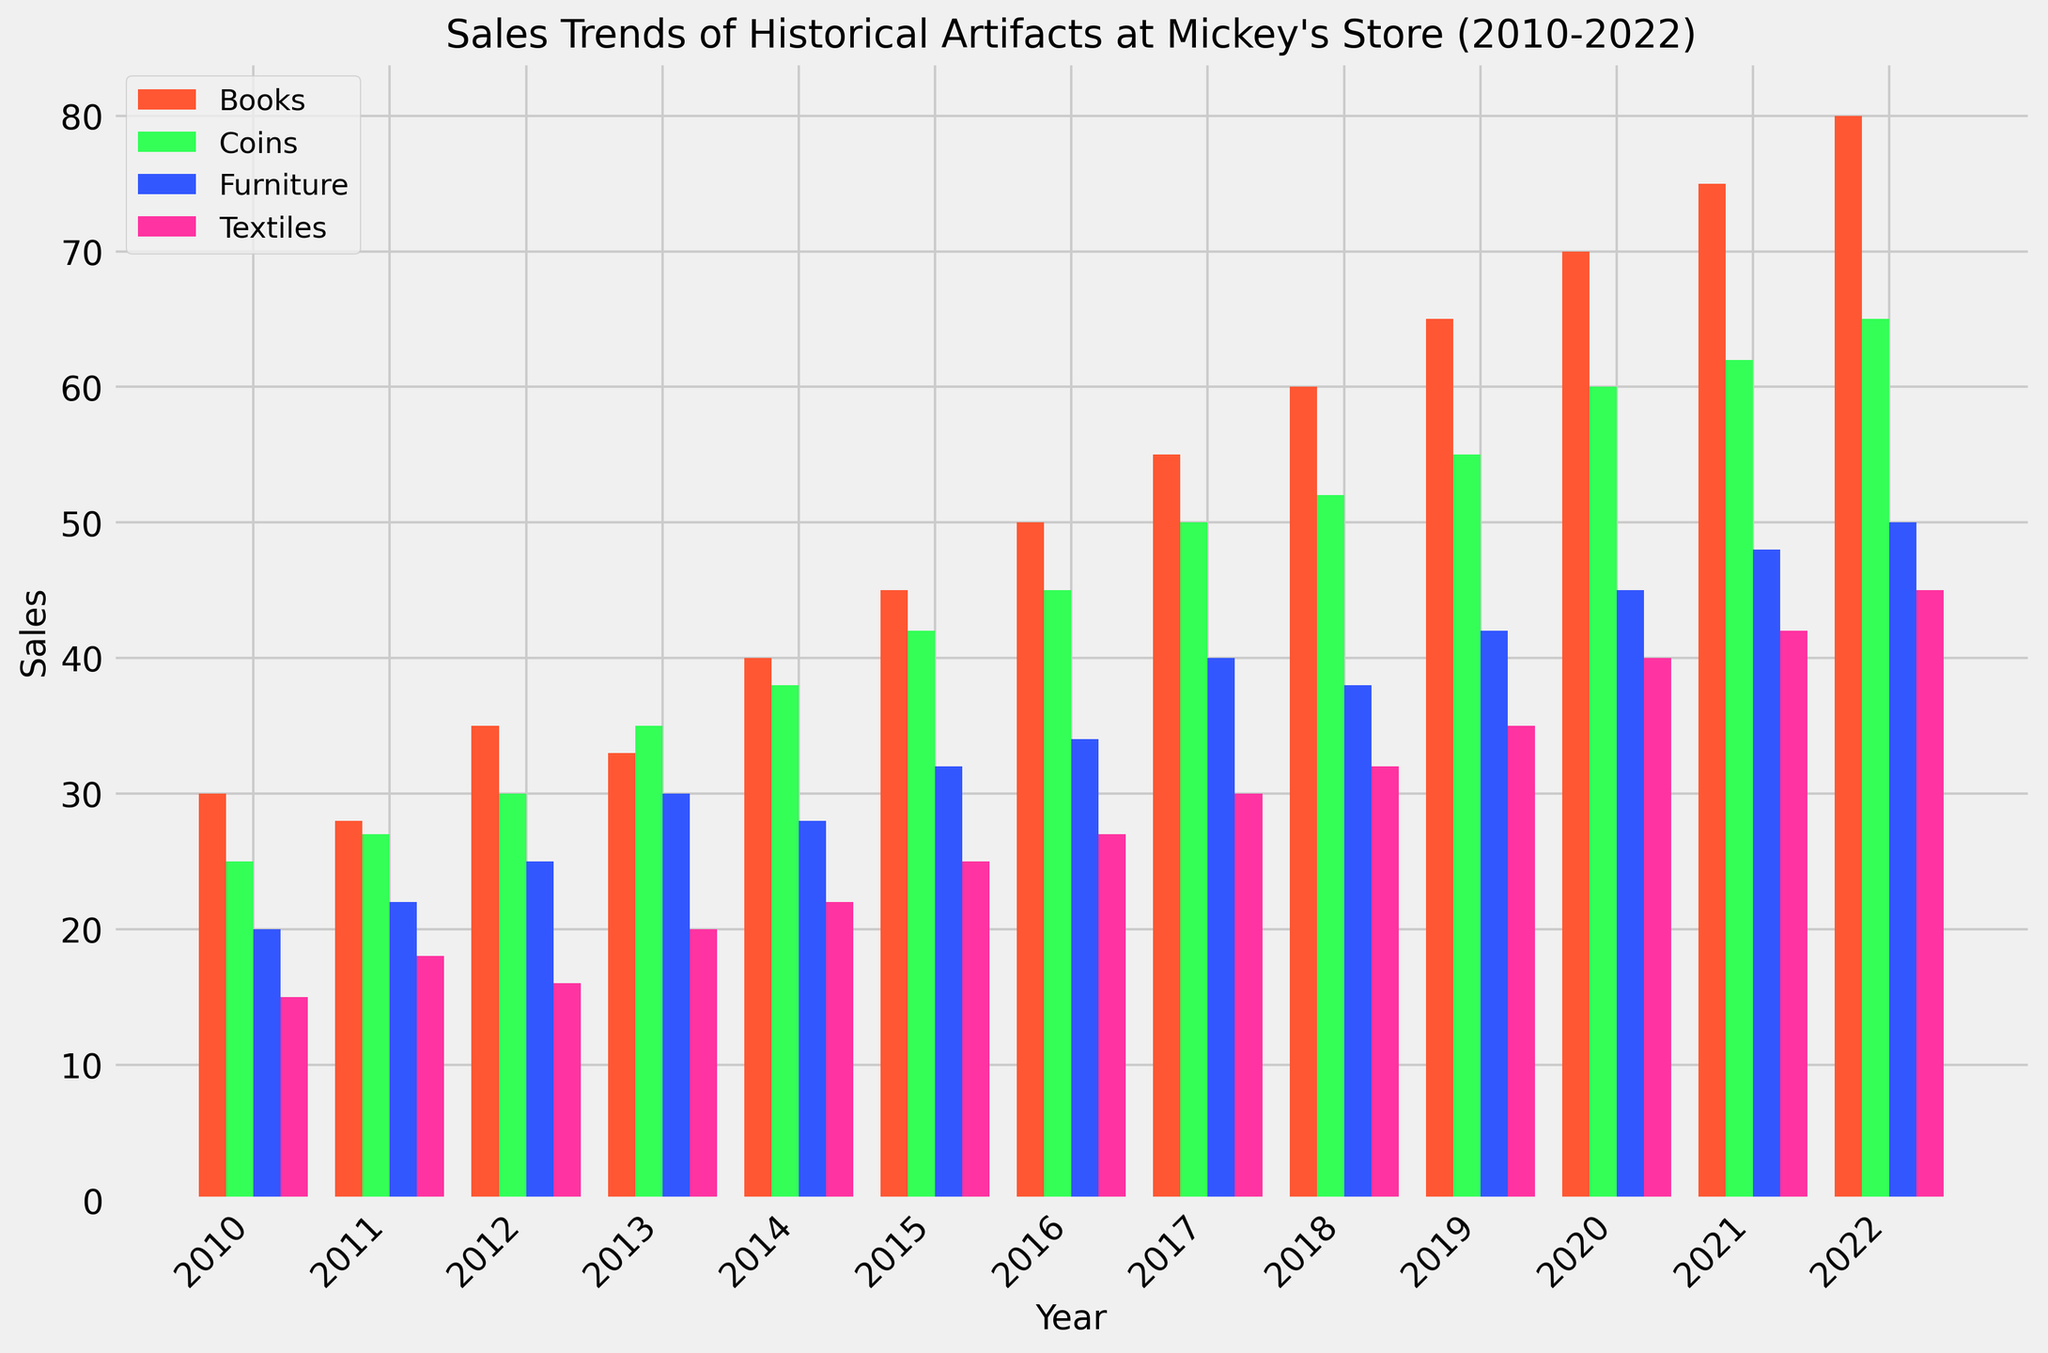What is the total sales of Books in 2015? Locate the bar corresponding to Books in 2015 and read its height, which is labeled as 45.
Answer: 45 Which year had the highest sales for Coins, and what was the value? Identify the tallest bar in the Coins category. The highest bar for Coins is in 2022, with a value of 65.
Answer: 2022, 65 Comparing sales of Furniture and Textiles in 2017, which category had more sales and by how much? Check the heights of the bars for Furniture and Textiles in 2017. Furniture has 40 sales, Textiles have 30. The difference is 40 - 30 = 10.
Answer: Furniture, 10 What is the average sales of Textiles from 2010 to 2022? Sum the sales values for Textiles from 2010 to 2022 and divide by the number of years (13). 
Sales: 15+18+16+20+22+25+27+30+32+35+40+42+45=367. Avg = 367/13 ≈ 28.23
Answer: 28.23 How did the sales of Books change from 2014 to 2022? Compare the heights of the bars for Books from 2014 to 2022. In 2014, the sales were 40; in 2022, the sales were 80. Find the difference: 80 - 40 = 40. Sales doubled over the period.
Answer: Doubled, 40 increase Which artifact category had the smallest growth in sales from 2010 to 2022, and what is the value difference? Calculate the sales difference from 2010 to 2022 for all categories: 
Textiles: 45 - 15 = 30
Furniture: 50 - 20 = 30
Books: 80 - 30 = 50
Coins: 65 - 25 = 40
The smallest growth is for Textiles and Furniture, with value 30.
Answer: Textiles and Furniture, 30 What is the total sales for all artifact categories combined in 2013? Sum of sales of all categories in 2013: 20 (Textiles) + 30 (Furniture) + 33 (Books) + 35 (Coins) = 118.
Answer: 118 In which year did Furniture first reach 40 sales? Locate the first year where the Furniture bar reaches 40 - that is 2017.
Answer: 2017 How many times did Coins' sales increase from 2010 to 2022? Compare the sales in 2010 and 2022 for Coins. In 2010: 25, in 2022: 65. Calculate the multiple: 65 / 25 = 2.6 times.
Answer: 2.6 times 